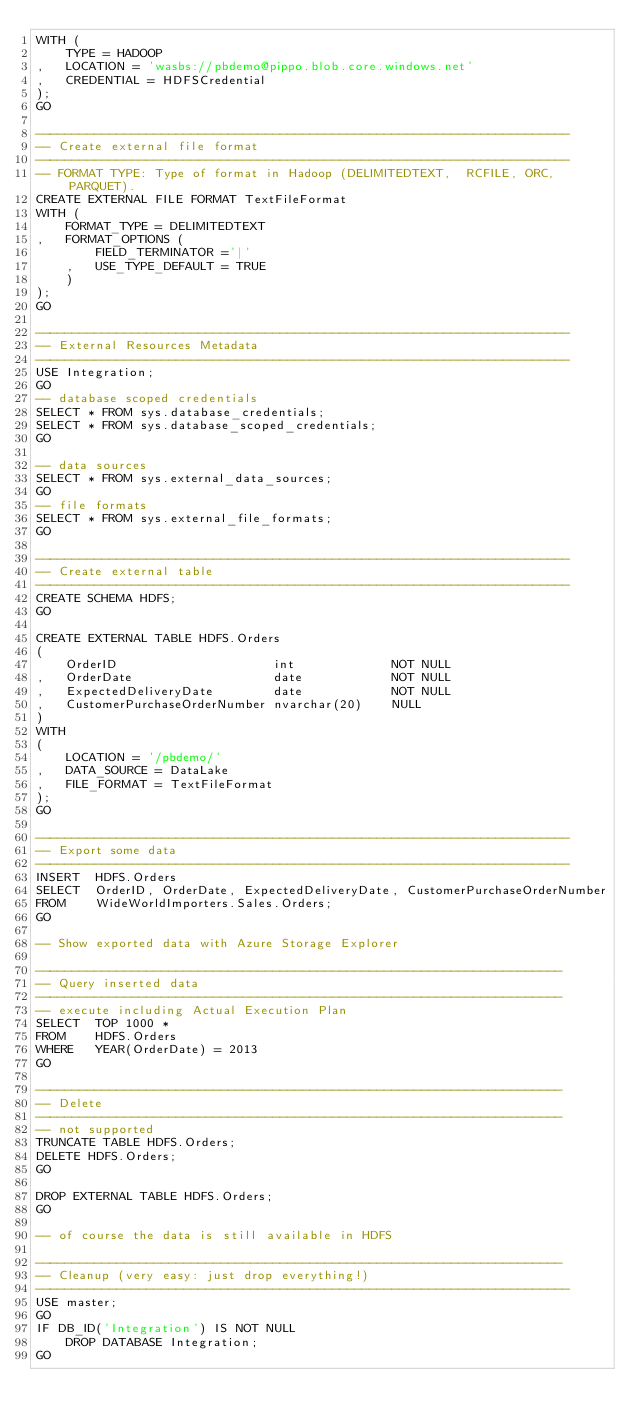Convert code to text. <code><loc_0><loc_0><loc_500><loc_500><_SQL_>WITH (
	TYPE = HADOOP
,	LOCATION = 'wasbs://pbdemo@pippo.blob.core.windows.net'
,	CREDENTIAL = HDFSCredential
);
GO

------------------------------------------------------------------------
-- Create external file format
------------------------------------------------------------------------
-- FORMAT TYPE: Type of format in Hadoop (DELIMITEDTEXT,  RCFILE, ORC, PARQUET).
CREATE EXTERNAL FILE FORMAT TextFileFormat
WITH (  
	FORMAT_TYPE = DELIMITEDTEXT
,	FORMAT_OPTIONS (
		FIELD_TERMINATOR ='|'
	,	USE_TYPE_DEFAULT = TRUE
	)
);
GO

------------------------------------------------------------------------
-- External Resources Metadata
------------------------------------------------------------------------
USE Integration;
GO
-- database scoped credentials
SELECT * FROM sys.database_credentials;
SELECT * FROM sys.database_scoped_credentials;
GO

-- data sources
SELECT * FROM sys.external_data_sources;
GO
-- file formats
SELECT * FROM sys.external_file_formats;
GO

------------------------------------------------------------------------
-- Create external table
------------------------------------------------------------------------
CREATE SCHEMA HDFS;
GO

CREATE EXTERNAL TABLE HDFS.Orders
(
	OrderID						int				NOT NULL
,	OrderDate					date			NOT NULL
,	ExpectedDeliveryDate		date			NOT NULL
,	CustomerPurchaseOrderNumber	nvarchar(20)	NULL
)
WITH
(
	LOCATION = '/pbdemo/'
,	DATA_SOURCE = DataLake
,	FILE_FORMAT = TextFileFormat
);
GO

------------------------------------------------------------------------
-- Export some data
------------------------------------------------------------------------
INSERT	HDFS.Orders
SELECT	OrderID, OrderDate, ExpectedDeliveryDate, CustomerPurchaseOrderNumber
FROM	WideWorldImporters.Sales.Orders;
GO

-- Show exported data with Azure Storage Explorer

-----------------------------------------------------------------------
-- Query inserted data
-----------------------------------------------------------------------
-- execute including Actual Execution Plan
SELECT	TOP 1000 *
FROM	HDFS.Orders
WHERE	YEAR(OrderDate) = 2013
GO

-----------------------------------------------------------------------
-- Delete
-----------------------------------------------------------------------
-- not supported 
TRUNCATE TABLE HDFS.Orders;
DELETE HDFS.Orders;
GO

DROP EXTERNAL TABLE HDFS.Orders;
GO

-- of course the data is still available in HDFS

-----------------------------------------------------------------------
-- Cleanup (very easy: just drop everything!)
------------------------------------------------------------------------
USE master;
GO
IF DB_ID('Integration') IS NOT NULL
	DROP DATABASE Integration;
GO


</code> 